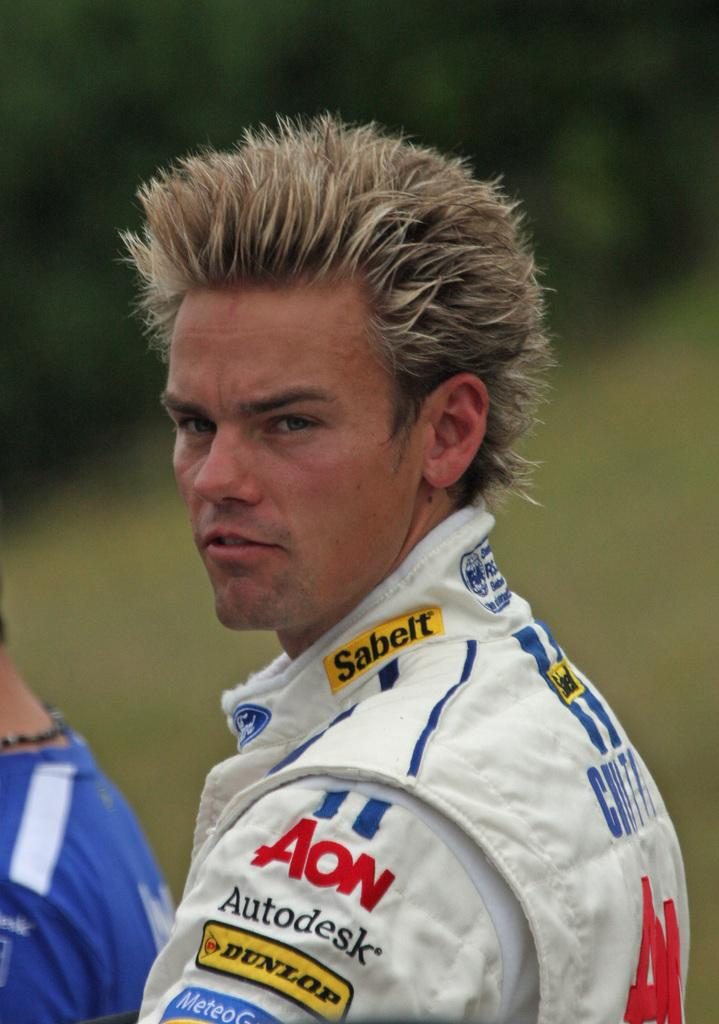<image>
Describe the image concisely. A man with spiked blonde hair is wearing a racing uniform that says Sabelt. 